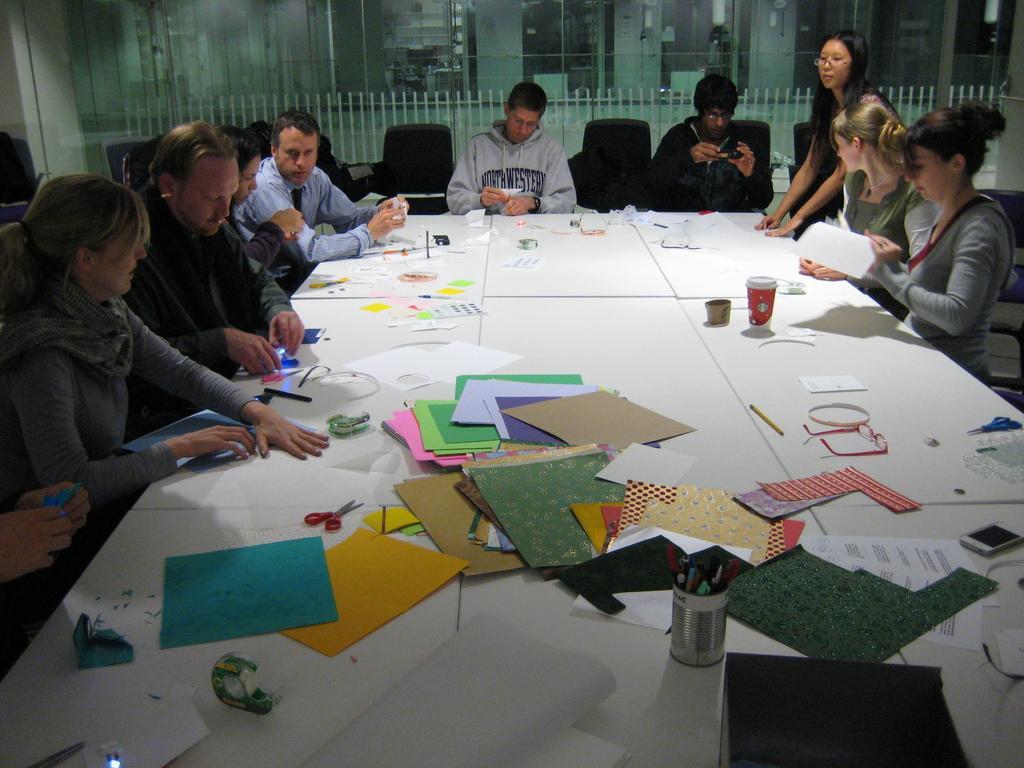Describe this image in one or two sentences. In this image, group of people are sat on the chair. In the middle, there is a white table, few many items are placed. At the right side, pa woman is standing. Back Side, we can see a glass window. 